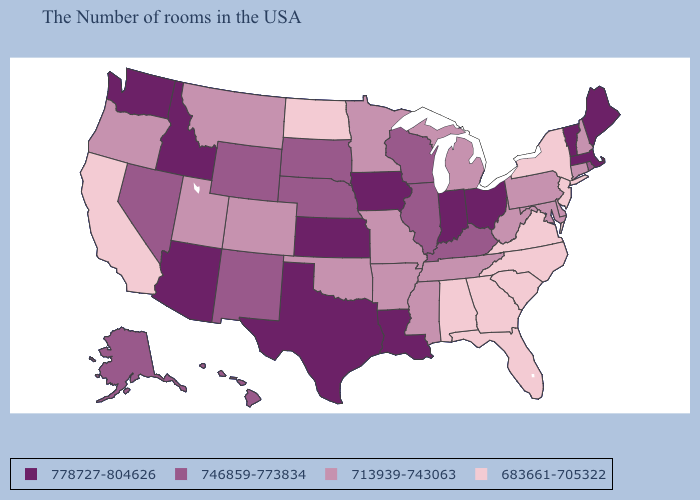Among the states that border Mississippi , does Louisiana have the highest value?
Write a very short answer. Yes. Which states hav the highest value in the Northeast?
Be succinct. Maine, Massachusetts, Vermont. Name the states that have a value in the range 778727-804626?
Give a very brief answer. Maine, Massachusetts, Vermont, Ohio, Indiana, Louisiana, Iowa, Kansas, Texas, Arizona, Idaho, Washington. Among the states that border South Dakota , does North Dakota have the lowest value?
Keep it brief. Yes. Among the states that border New Hampshire , which have the highest value?
Keep it brief. Maine, Massachusetts, Vermont. Does Alaska have the highest value in the West?
Write a very short answer. No. What is the lowest value in states that border South Carolina?
Be succinct. 683661-705322. Among the states that border Pennsylvania , which have the highest value?
Be succinct. Ohio. What is the value of Alaska?
Quick response, please. 746859-773834. Which states have the lowest value in the USA?
Write a very short answer. New York, New Jersey, Virginia, North Carolina, South Carolina, Florida, Georgia, Alabama, North Dakota, California. What is the lowest value in the USA?
Answer briefly. 683661-705322. Does the first symbol in the legend represent the smallest category?
Short answer required. No. What is the value of Maryland?
Quick response, please. 713939-743063. Does South Carolina have the lowest value in the USA?
Concise answer only. Yes. 